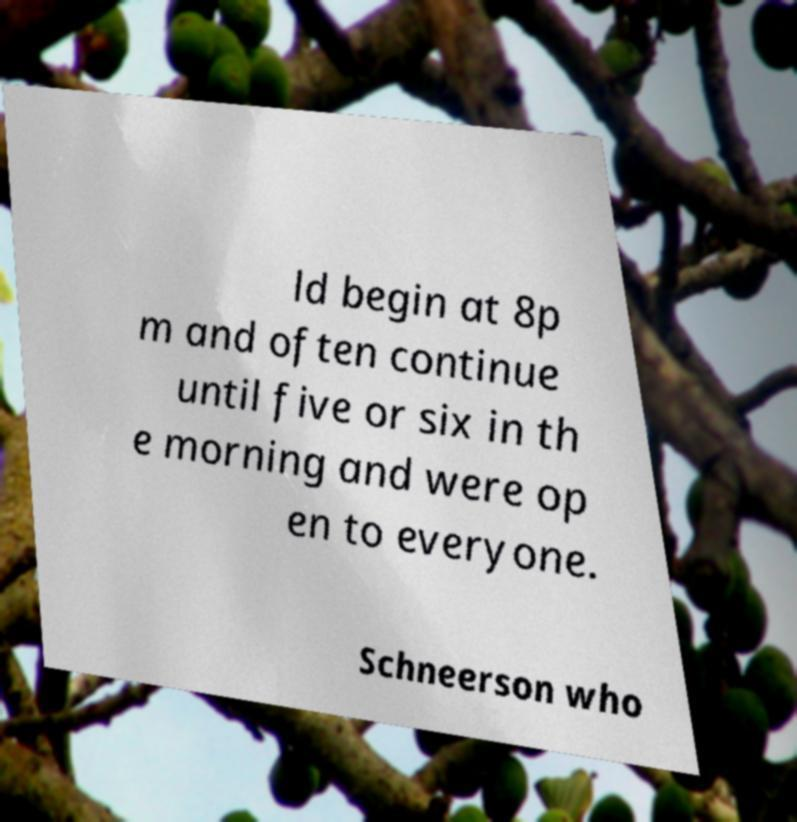Please identify and transcribe the text found in this image. ld begin at 8p m and often continue until five or six in th e morning and were op en to everyone. Schneerson who 